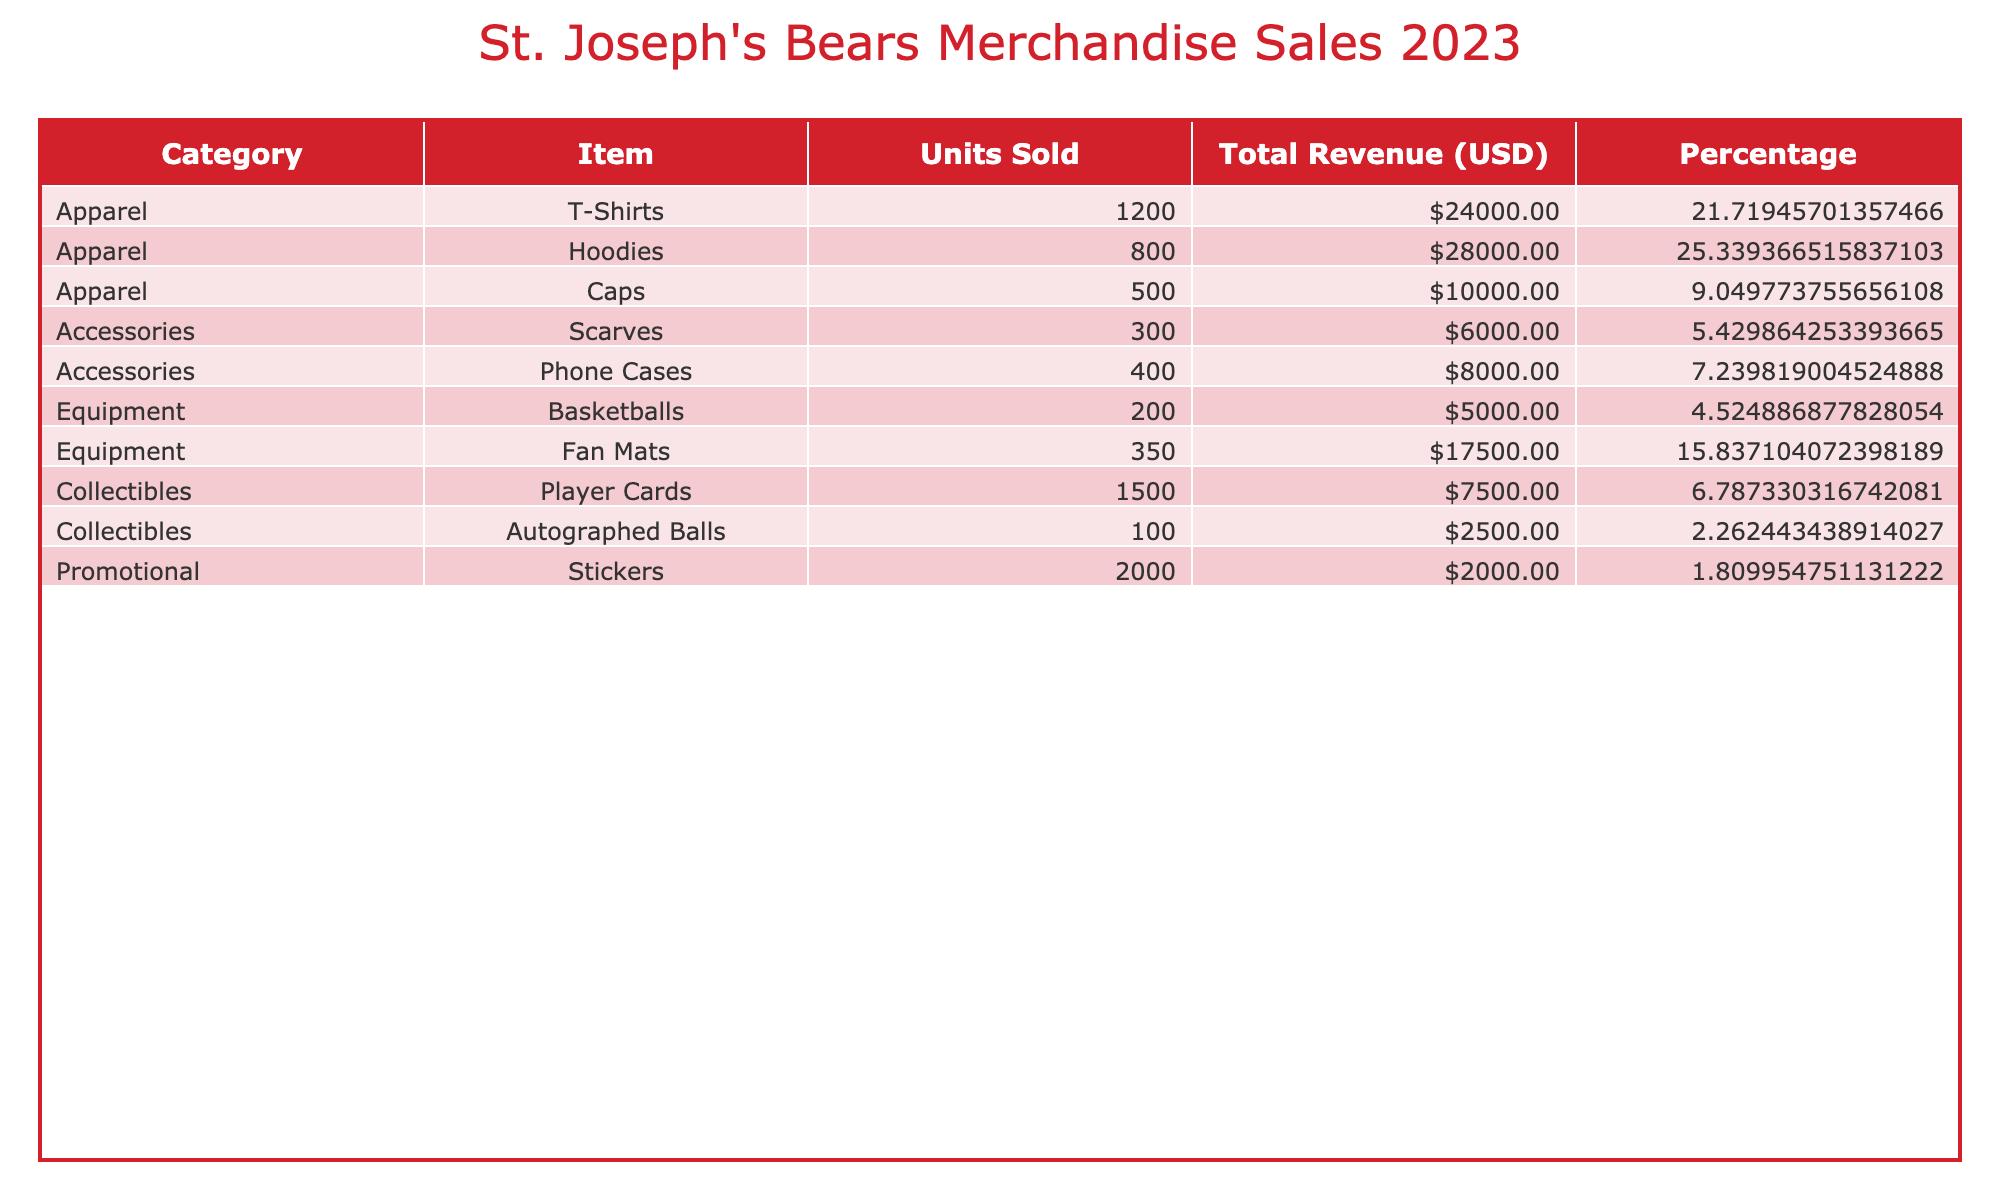What is the total revenue generated from merchandise sales for the St. Joseph's Bears? To find the total revenue, we sum up the values in the 'Total Revenue (USD)' column: 24000 + 28000 + 10000 + 6000 + 8000 + 5000 + 17500 + 7500 + 2500 + 2000 = 100000.
Answer: 100000 Which item had the highest revenue, and how much was it? The item with the highest revenue is Hoodies with a total revenue of 28000 USD. We can see this by comparing the 'Total Revenue (USD)' for all items.
Answer: Hoodies, 28000 What percentage of the total revenue was generated from Apparel? To calculate the percentage from Apparel, first, sum the revenues for Apparel items: 24000 + 28000 + 10000 = 62000. Then, divide by the total revenue (100000) and multiply by 100: (62000 / 100000) * 100 = 62%.
Answer: 62% Did the St. Joseph's Bears sell more Accessories or Equipment in terms of total revenue? For Accessories, the total revenue is 6000 + 8000 = 14000. For Equipment, it is 5000 + 17500 = 22500. Since 22500 (Equipment) is greater than 14000 (Accessories), they sold more Equipment in terms of revenue.
Answer: Equipment What is the average revenue generated by Collectibles? The total revenue from Collectibles is 7500 + 2500 = 10000. There are two items in this category, so the average is 10000 divided by 2, which equals 5000.
Answer: 5000 Is the revenue from Promotional items greater than 50% of the total revenue? The revenue from Promotional items is 2000. To find if it's greater than 50%, we look at 50% of the total revenue (100000), which is 50000. Since 2000 is much less than 50000, the statement is false.
Answer: No Which item sold the least units, and how many were sold? The item that sold the least units is Autographed Balls, with only 100 units sold. This can be understood by scanning the 'Units Sold' column for the lowest number.
Answer: Autographed Balls, 100 What is the revenue difference between T-Shirts and Caps? The revenue from T-Shirts is 24000 and from Caps is 10000. The difference is calculated as 24000 - 10000 = 14000.
Answer: 14000 Which category generated the most revenue overall? The total revenue for each category is: Apparel (62000), Accessories (14000), Equipment (22500), Collectibles (10000), and Promotional (2000). The category with the highest amount is Apparel with 62000 USD.
Answer: Apparel 